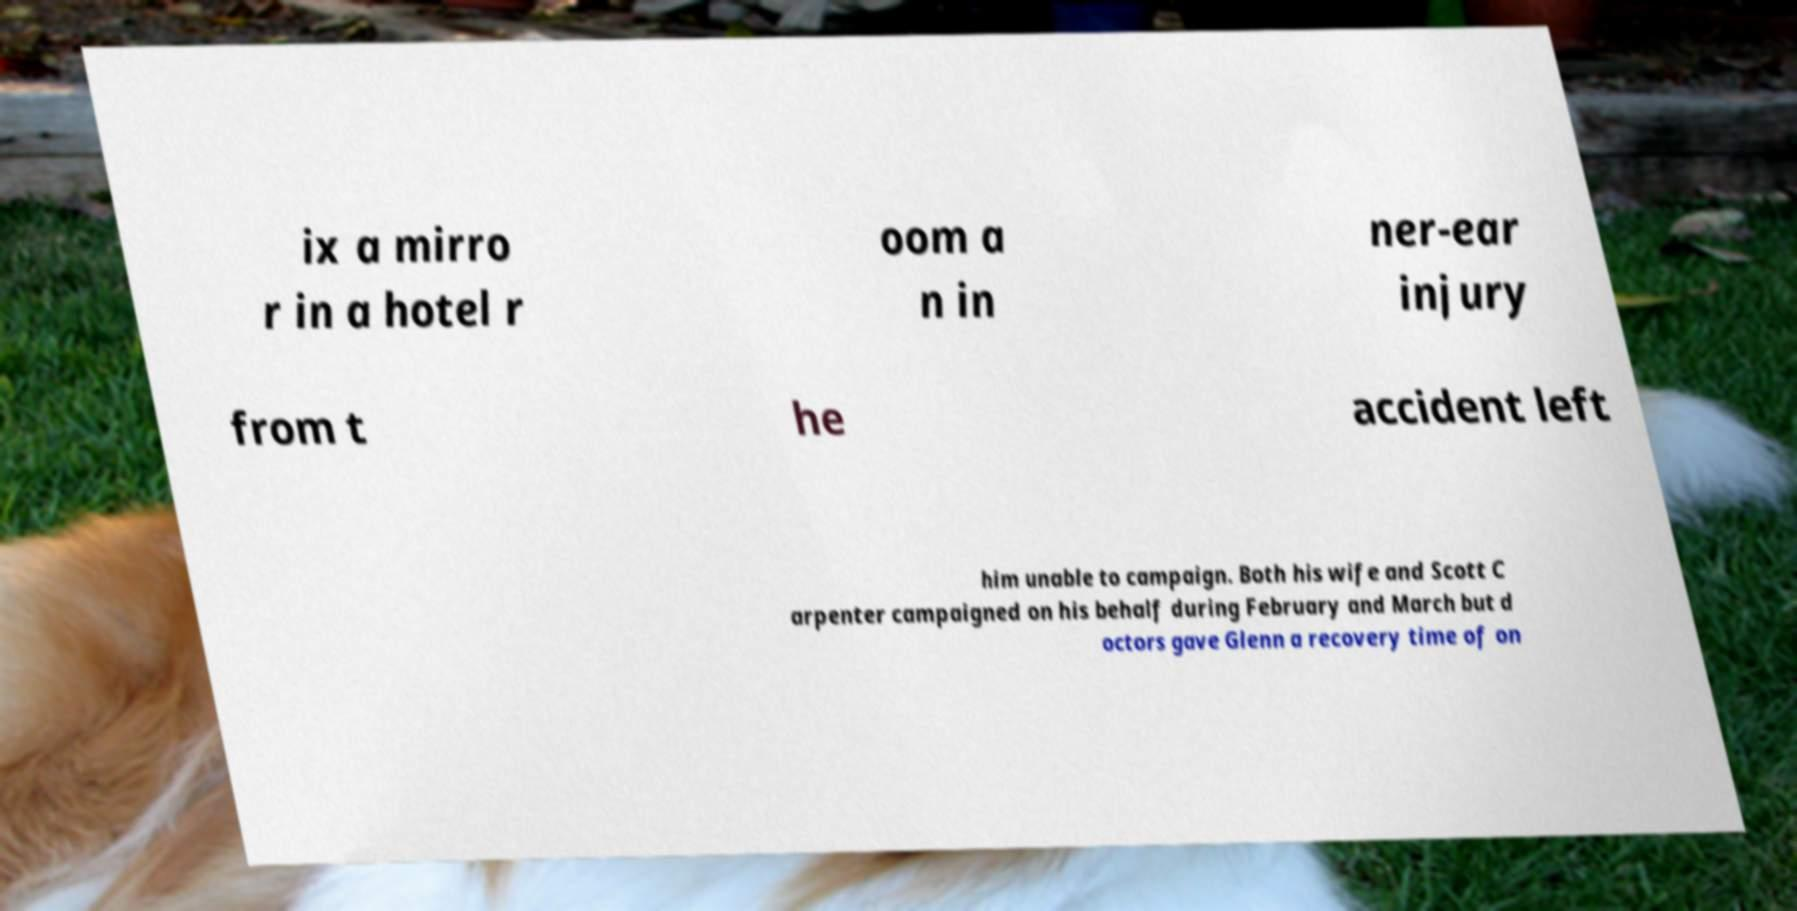Could you extract and type out the text from this image? ix a mirro r in a hotel r oom a n in ner-ear injury from t he accident left him unable to campaign. Both his wife and Scott C arpenter campaigned on his behalf during February and March but d octors gave Glenn a recovery time of on 